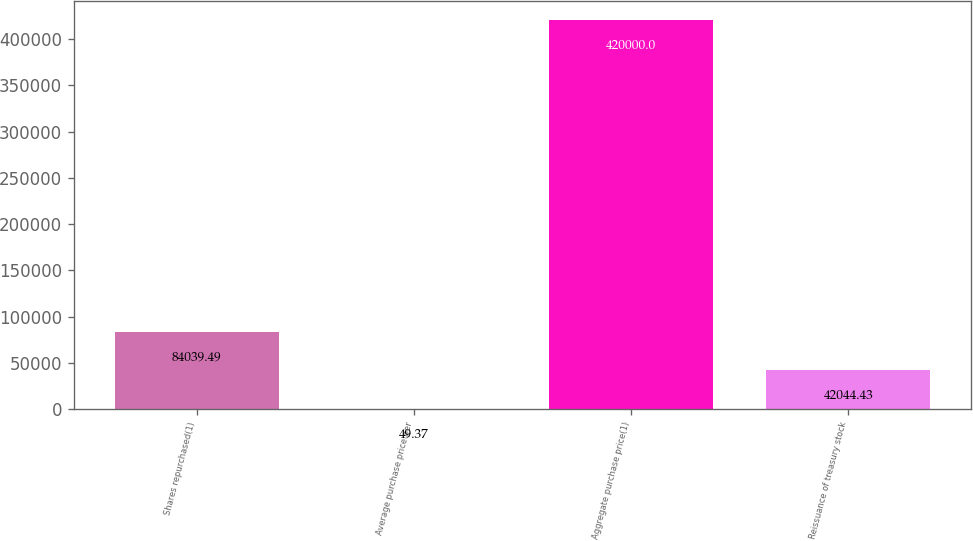Convert chart. <chart><loc_0><loc_0><loc_500><loc_500><bar_chart><fcel>Shares repurchased(1)<fcel>Average purchase price per<fcel>Aggregate purchase price(1)<fcel>Reissuance of treasury stock<nl><fcel>84039.5<fcel>49.37<fcel>420000<fcel>42044.4<nl></chart> 